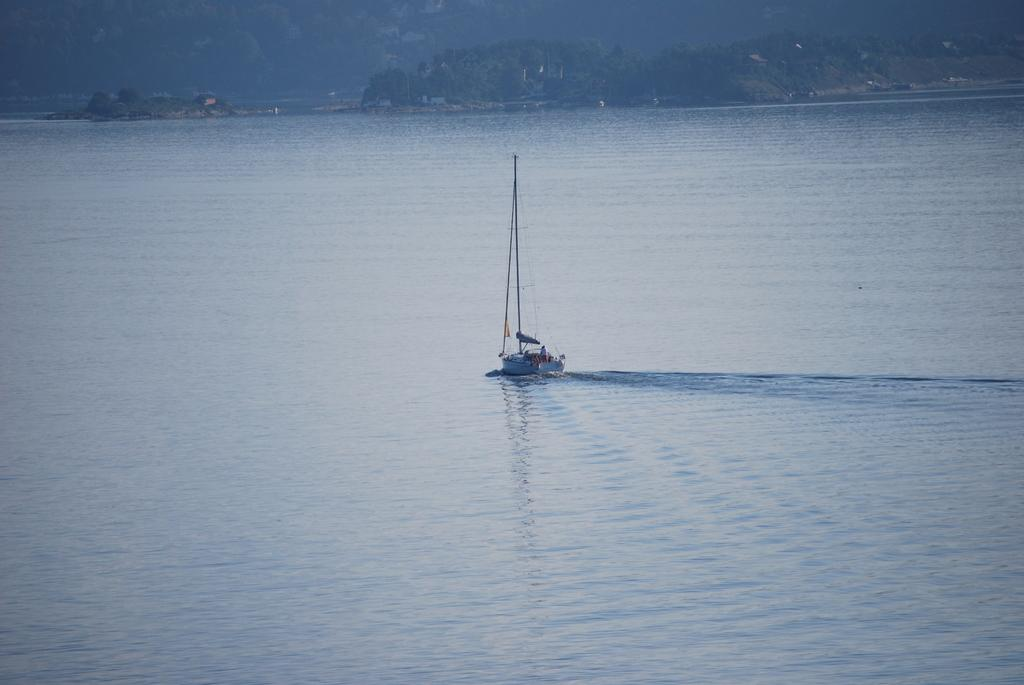What is the main feature of the landscape in the image? There is a water surface in the image. What type of vehicle is present on the water surface? There is a boat with a pole and wire in the image. What can be seen in the background of the image? There are hills with trees in the image. Are there any signs of human habitation in the image? Yes, there are houses near the hills in the image. What type of advertisement can be seen on the boat in the image? There is no advertisement present on the boat in the image. What color is the quince that is being held by the partner in the image? There is no partner or quince present in the image. 